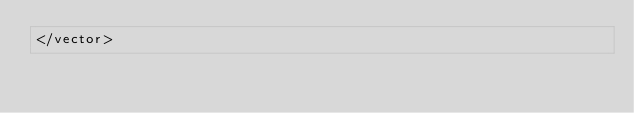Convert code to text. <code><loc_0><loc_0><loc_500><loc_500><_XML_></vector>
</code> 